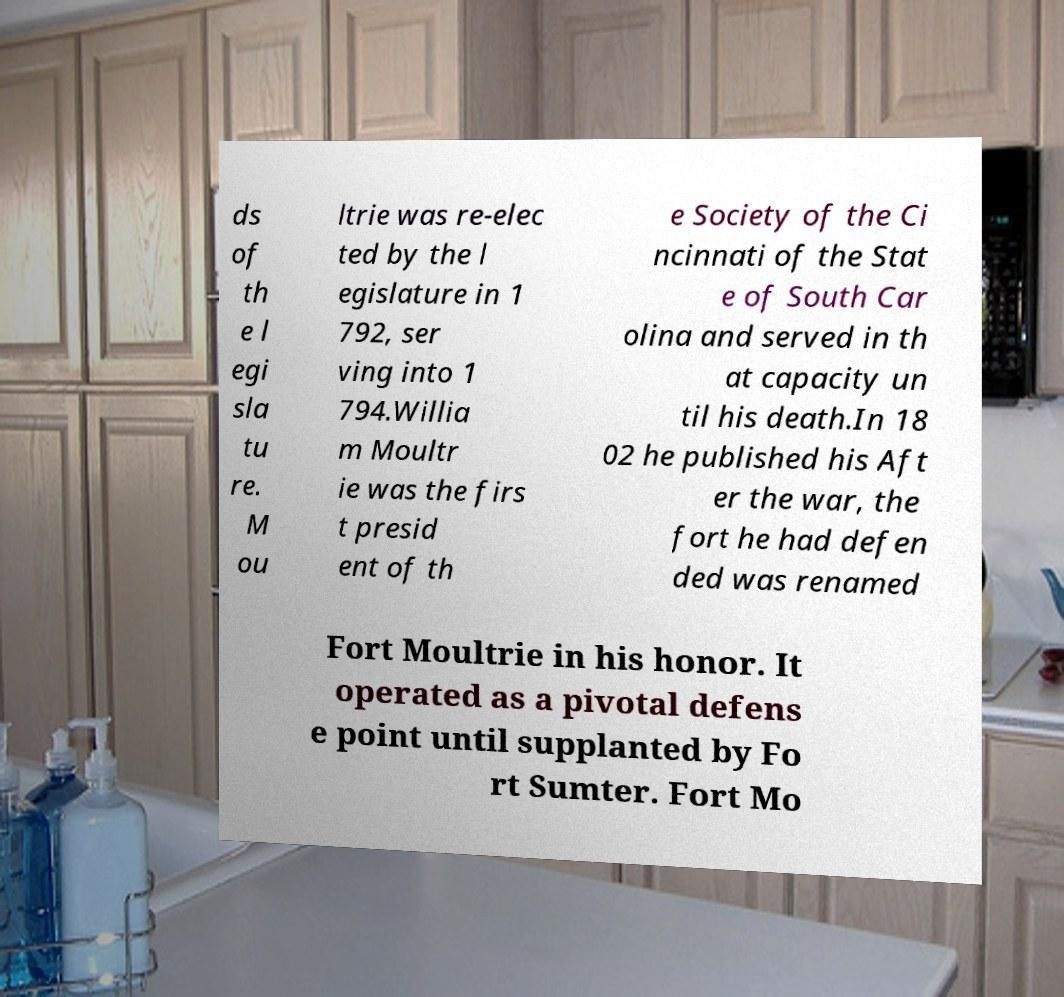Please identify and transcribe the text found in this image. ds of th e l egi sla tu re. M ou ltrie was re-elec ted by the l egislature in 1 792, ser ving into 1 794.Willia m Moultr ie was the firs t presid ent of th e Society of the Ci ncinnati of the Stat e of South Car olina and served in th at capacity un til his death.In 18 02 he published his Aft er the war, the fort he had defen ded was renamed Fort Moultrie in his honor. It operated as a pivotal defens e point until supplanted by Fo rt Sumter. Fort Mo 